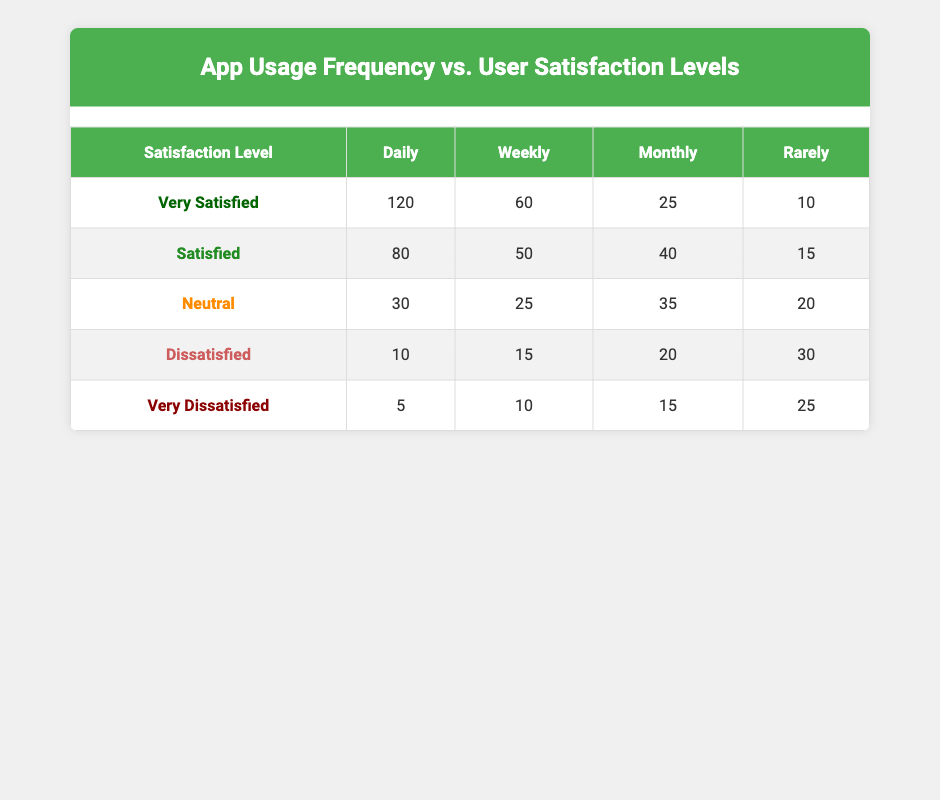What is the highest number of users who reported being "Very Satisfied"? The highest number of users who reported being "Very Satisfied" is in the Daily category, with 120 users.
Answer: 120 How many users are "Dissatisfied" when using the app weekly? The number of users who are "Dissatisfied" in the Weekly category is 15.
Answer: 15 What is the total number of "Neutral" users across all frequency categories? To find the total number of "Neutral" users, we add the values: 30 (Daily) + 25 (Weekly) + 35 (Monthly) + 20 (Rarely) = 110.
Answer: 110 Are there more users who are "Satisfied" or "Very Satisfied" when using the app Monthly? There are 40 users who are "Satisfied" and 25 users who are "Very Satisfied" in the Monthly category. Since 40 is greater than 25, there are more "Satisfied" users.
Answer: Yes What percentage of users are "Very Dissatisfied" when using the app Rarely? There are 25 "Very Dissatisfied" users in the Rarely category out of a total of 100 users (10 + 15 + 20 + 30 + 25). To calculate the percentage: (25 / 100) * 100 = 25%.
Answer: 25% What is the difference in the number of "Very Satisfied" users between Daily and Rarely frequency? The number of "Very Satisfied" users in the Daily frequency is 120, compared to 10 in the Rarely frequency. The difference is 120 - 10 = 110.
Answer: 110 How many total users responded for the "Monthly" usage frequency? To find the total users for the Monthly usage, we sum the number of respondents for all satisfaction levels: 25 (Very Satisfied) + 40 (Satisfied) + 35 (Neutral) + 20 (Dissatisfied) + 15 (Very Dissatisfied) = 135.
Answer: 135 Which frequency category has the highest number of "Dissatisfied" users? In the table, the Rarely category has the highest number of "Dissatisfied" users with 30, compared to 10 (Daily), 15 (Weekly), and 20 (Monthly).
Answer: Rarely What is the average number of "Satisfied" users across all frequency categories? To find the average, we first sum the "Satisfied" users: 80 (Daily) + 50 (Weekly) + 40 (Monthly) + 15 (Rarely) = 185. Then, we divide by the number of frequency categories, which is 4: 185 / 4 = 46.25.
Answer: 46.25 